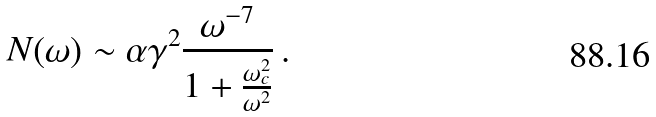Convert formula to latex. <formula><loc_0><loc_0><loc_500><loc_500>N ( \omega ) \sim \alpha \gamma ^ { 2 } \frac { \omega ^ { - 7 } } { 1 + \frac { \omega ^ { 2 } _ { c } } { \omega ^ { 2 } } } \, .</formula> 